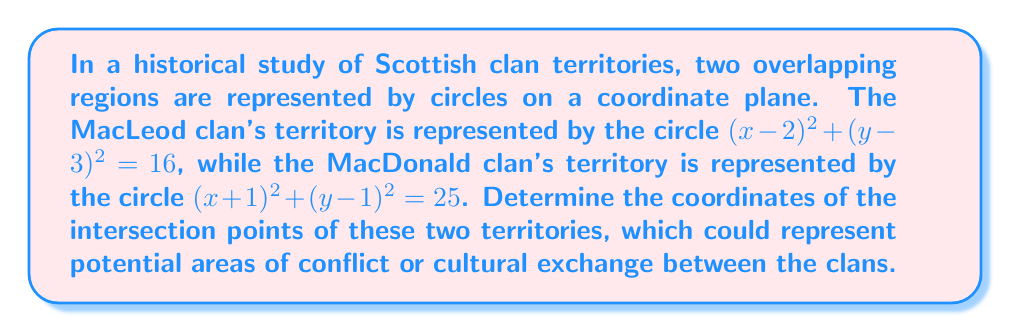Can you answer this question? Let's approach this step-by-step:

1) We have two circle equations:
   MacLeod: $(x-2)^2 + (y-3)^2 = 16$
   MacDonald: $(x+1)^2 + (y-1)^2 = 25$

2) To find the intersection points, we need to solve these equations simultaneously.

3) Expand the equations:
   MacLeod: $x^2 - 4x + 4 + y^2 - 6y + 9 = 16$
   MacDonald: $x^2 + 2x + 1 + y^2 - 2y + 1 = 25$

4) Simplify:
   MacLeod: $x^2 + y^2 - 4x - 6y - 3 = 0$
   MacDonald: $x^2 + y^2 + 2x - 2y - 23 = 0$

5) Subtract the MacLeod equation from the MacDonald equation:
   $6x + 4y - 20 = 0$

6) Solve this for y:
   $y = 5 - \frac{3x}{2}$

7) Substitute this into the MacLeod equation:
   $x^2 + (5 - \frac{3x}{2})^2 - 4x - 6(5 - \frac{3x}{2}) - 3 = 0$

8) Expand and simplify:
   $x^2 + 25 - 15x + \frac{9x^2}{4} - 4x - 30 + 9x - 3 = 0$
   $\frac{13x^2}{4} - 10x - 8 = 0$

9) Multiply all terms by 4:
   $13x^2 - 40x - 32 = 0$

10) This is a quadratic equation. Solve using the quadratic formula:
    $x = \frac{40 \pm \sqrt{1600 + 1664}}{26} = \frac{40 \pm \sqrt{3264}}{26} = \frac{40 \pm 57.13}{26}$

11) Therefore:
    $x_1 = \frac{40 + 57.13}{26} \approx 3.74$
    $x_2 = \frac{40 - 57.13}{26} \approx -0.66$

12) Substitute these x-values back into the equation from step 6 to find y:
    For $x_1$: $y_1 = 5 - \frac{3(3.74)}{2} \approx 0.39$
    For $x_2$: $y_2 = 5 - \frac{3(-0.66)}{2} \approx 5.99$

Therefore, the intersection points are approximately (3.74, 0.39) and (-0.66, 5.99).
Answer: (3.74, 0.39) and (-0.66, 5.99) 